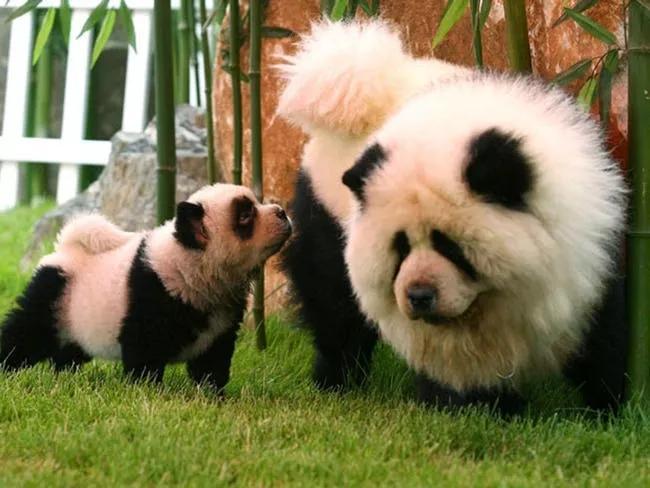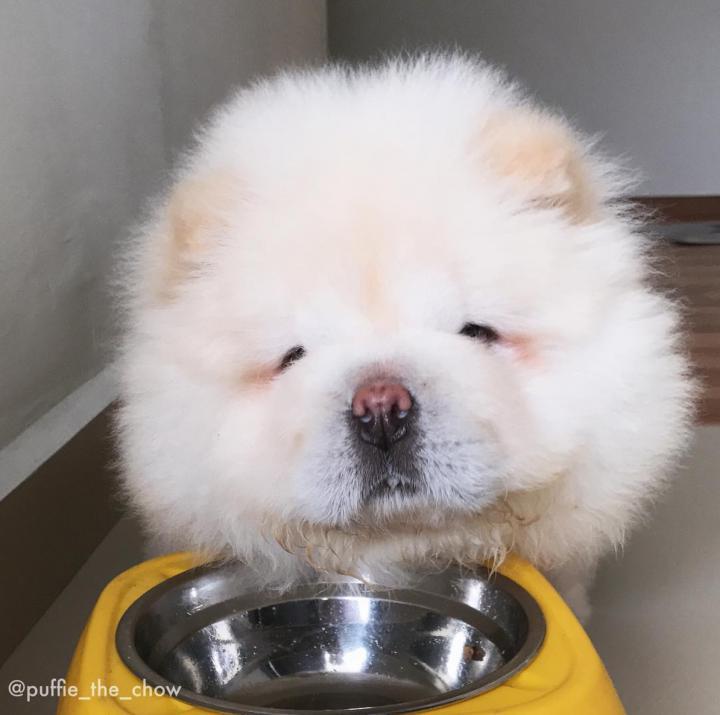The first image is the image on the left, the second image is the image on the right. Given the left and right images, does the statement "Exactly two dogs can be seen to be standing, and have their white tails curled up and laying on their backs" hold true? Answer yes or no. Yes. The first image is the image on the left, the second image is the image on the right. Examine the images to the left and right. Is the description "There are three animals" accurate? Answer yes or no. Yes. The first image is the image on the left, the second image is the image on the right. Given the left and right images, does the statement "The dog in the right image is looking towards the right." hold true? Answer yes or no. No. 